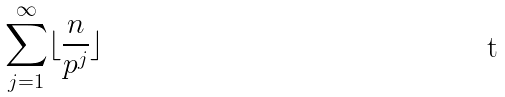<formula> <loc_0><loc_0><loc_500><loc_500>\sum _ { j = 1 } ^ { \infty } \lfloor \frac { n } { p ^ { j } } \rfloor</formula> 